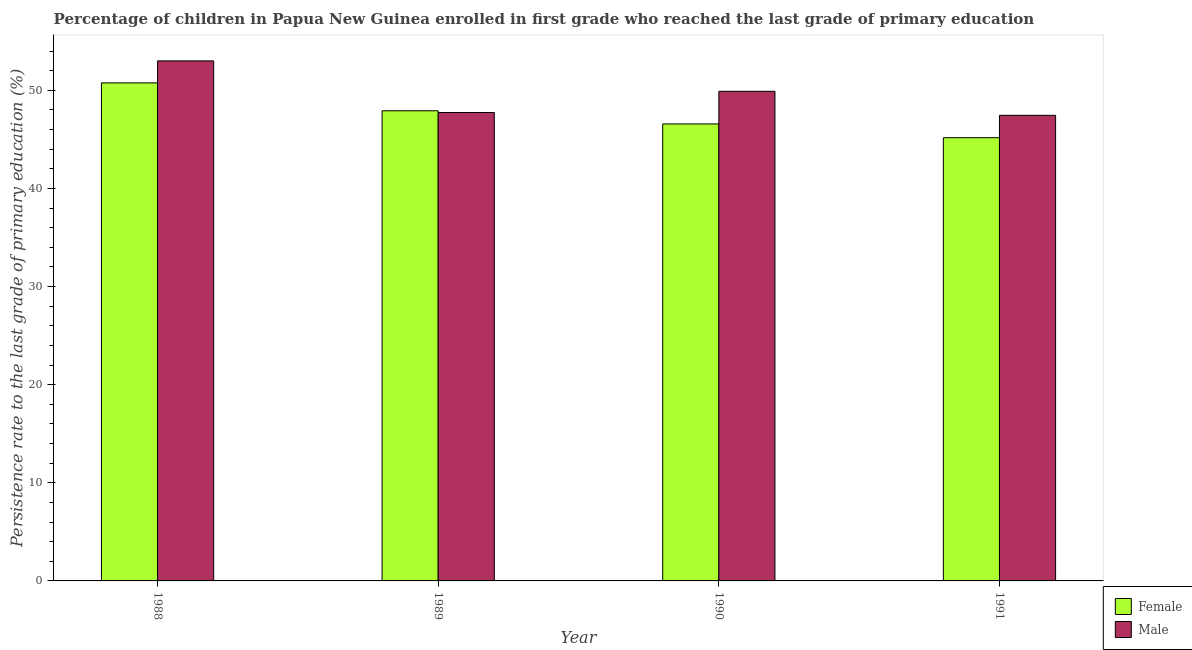How many different coloured bars are there?
Keep it short and to the point. 2. How many groups of bars are there?
Ensure brevity in your answer.  4. Are the number of bars per tick equal to the number of legend labels?
Provide a succinct answer. Yes. How many bars are there on the 3rd tick from the right?
Give a very brief answer. 2. What is the label of the 2nd group of bars from the left?
Provide a succinct answer. 1989. What is the persistence rate of female students in 1990?
Your answer should be very brief. 46.58. Across all years, what is the maximum persistence rate of male students?
Provide a succinct answer. 53.01. Across all years, what is the minimum persistence rate of female students?
Your answer should be compact. 45.18. In which year was the persistence rate of male students maximum?
Your response must be concise. 1988. What is the total persistence rate of male students in the graph?
Keep it short and to the point. 198.11. What is the difference between the persistence rate of female students in 1988 and that in 1991?
Your response must be concise. 5.58. What is the difference between the persistence rate of male students in 1988 and the persistence rate of female students in 1989?
Offer a terse response. 5.26. What is the average persistence rate of male students per year?
Your answer should be very brief. 49.53. In how many years, is the persistence rate of female students greater than 44 %?
Offer a very short reply. 4. What is the ratio of the persistence rate of female students in 1989 to that in 1990?
Provide a succinct answer. 1.03. What is the difference between the highest and the second highest persistence rate of male students?
Provide a succinct answer. 3.1. What is the difference between the highest and the lowest persistence rate of female students?
Your response must be concise. 5.58. In how many years, is the persistence rate of male students greater than the average persistence rate of male students taken over all years?
Provide a short and direct response. 2. What does the 1st bar from the right in 1988 represents?
Your answer should be very brief. Male. What is the difference between two consecutive major ticks on the Y-axis?
Your response must be concise. 10. Are the values on the major ticks of Y-axis written in scientific E-notation?
Provide a short and direct response. No. Does the graph contain any zero values?
Your response must be concise. No. Where does the legend appear in the graph?
Provide a short and direct response. Bottom right. How many legend labels are there?
Offer a terse response. 2. How are the legend labels stacked?
Offer a terse response. Vertical. What is the title of the graph?
Make the answer very short. Percentage of children in Papua New Guinea enrolled in first grade who reached the last grade of primary education. What is the label or title of the X-axis?
Your answer should be very brief. Year. What is the label or title of the Y-axis?
Make the answer very short. Persistence rate to the last grade of primary education (%). What is the Persistence rate to the last grade of primary education (%) of Female in 1988?
Provide a short and direct response. 50.76. What is the Persistence rate to the last grade of primary education (%) of Male in 1988?
Offer a very short reply. 53.01. What is the Persistence rate to the last grade of primary education (%) in Female in 1989?
Make the answer very short. 47.92. What is the Persistence rate to the last grade of primary education (%) of Male in 1989?
Ensure brevity in your answer.  47.74. What is the Persistence rate to the last grade of primary education (%) in Female in 1990?
Provide a succinct answer. 46.58. What is the Persistence rate to the last grade of primary education (%) in Male in 1990?
Give a very brief answer. 49.9. What is the Persistence rate to the last grade of primary education (%) in Female in 1991?
Your answer should be compact. 45.18. What is the Persistence rate to the last grade of primary education (%) in Male in 1991?
Your answer should be compact. 47.46. Across all years, what is the maximum Persistence rate to the last grade of primary education (%) in Female?
Give a very brief answer. 50.76. Across all years, what is the maximum Persistence rate to the last grade of primary education (%) in Male?
Offer a terse response. 53.01. Across all years, what is the minimum Persistence rate to the last grade of primary education (%) of Female?
Your answer should be compact. 45.18. Across all years, what is the minimum Persistence rate to the last grade of primary education (%) in Male?
Your answer should be compact. 47.46. What is the total Persistence rate to the last grade of primary education (%) in Female in the graph?
Offer a very short reply. 190.43. What is the total Persistence rate to the last grade of primary education (%) in Male in the graph?
Your answer should be compact. 198.11. What is the difference between the Persistence rate to the last grade of primary education (%) in Female in 1988 and that in 1989?
Offer a very short reply. 2.84. What is the difference between the Persistence rate to the last grade of primary education (%) in Male in 1988 and that in 1989?
Make the answer very short. 5.26. What is the difference between the Persistence rate to the last grade of primary education (%) in Female in 1988 and that in 1990?
Provide a short and direct response. 4.18. What is the difference between the Persistence rate to the last grade of primary education (%) of Male in 1988 and that in 1990?
Make the answer very short. 3.1. What is the difference between the Persistence rate to the last grade of primary education (%) of Female in 1988 and that in 1991?
Offer a terse response. 5.58. What is the difference between the Persistence rate to the last grade of primary education (%) in Male in 1988 and that in 1991?
Make the answer very short. 5.55. What is the difference between the Persistence rate to the last grade of primary education (%) of Female in 1989 and that in 1990?
Keep it short and to the point. 1.34. What is the difference between the Persistence rate to the last grade of primary education (%) of Male in 1989 and that in 1990?
Provide a short and direct response. -2.16. What is the difference between the Persistence rate to the last grade of primary education (%) in Female in 1989 and that in 1991?
Keep it short and to the point. 2.74. What is the difference between the Persistence rate to the last grade of primary education (%) of Male in 1989 and that in 1991?
Make the answer very short. 0.29. What is the difference between the Persistence rate to the last grade of primary education (%) of Female in 1990 and that in 1991?
Keep it short and to the point. 1.4. What is the difference between the Persistence rate to the last grade of primary education (%) in Male in 1990 and that in 1991?
Your answer should be compact. 2.45. What is the difference between the Persistence rate to the last grade of primary education (%) in Female in 1988 and the Persistence rate to the last grade of primary education (%) in Male in 1989?
Provide a succinct answer. 3.02. What is the difference between the Persistence rate to the last grade of primary education (%) of Female in 1988 and the Persistence rate to the last grade of primary education (%) of Male in 1990?
Give a very brief answer. 0.86. What is the difference between the Persistence rate to the last grade of primary education (%) in Female in 1988 and the Persistence rate to the last grade of primary education (%) in Male in 1991?
Keep it short and to the point. 3.3. What is the difference between the Persistence rate to the last grade of primary education (%) in Female in 1989 and the Persistence rate to the last grade of primary education (%) in Male in 1990?
Provide a succinct answer. -1.99. What is the difference between the Persistence rate to the last grade of primary education (%) of Female in 1989 and the Persistence rate to the last grade of primary education (%) of Male in 1991?
Offer a very short reply. 0.46. What is the difference between the Persistence rate to the last grade of primary education (%) of Female in 1990 and the Persistence rate to the last grade of primary education (%) of Male in 1991?
Keep it short and to the point. -0.88. What is the average Persistence rate to the last grade of primary education (%) of Female per year?
Offer a terse response. 47.61. What is the average Persistence rate to the last grade of primary education (%) of Male per year?
Your response must be concise. 49.53. In the year 1988, what is the difference between the Persistence rate to the last grade of primary education (%) of Female and Persistence rate to the last grade of primary education (%) of Male?
Provide a succinct answer. -2.25. In the year 1989, what is the difference between the Persistence rate to the last grade of primary education (%) in Female and Persistence rate to the last grade of primary education (%) in Male?
Give a very brief answer. 0.18. In the year 1990, what is the difference between the Persistence rate to the last grade of primary education (%) of Female and Persistence rate to the last grade of primary education (%) of Male?
Keep it short and to the point. -3.33. In the year 1991, what is the difference between the Persistence rate to the last grade of primary education (%) of Female and Persistence rate to the last grade of primary education (%) of Male?
Your response must be concise. -2.28. What is the ratio of the Persistence rate to the last grade of primary education (%) of Female in 1988 to that in 1989?
Offer a very short reply. 1.06. What is the ratio of the Persistence rate to the last grade of primary education (%) in Male in 1988 to that in 1989?
Keep it short and to the point. 1.11. What is the ratio of the Persistence rate to the last grade of primary education (%) in Female in 1988 to that in 1990?
Keep it short and to the point. 1.09. What is the ratio of the Persistence rate to the last grade of primary education (%) in Male in 1988 to that in 1990?
Give a very brief answer. 1.06. What is the ratio of the Persistence rate to the last grade of primary education (%) of Female in 1988 to that in 1991?
Give a very brief answer. 1.12. What is the ratio of the Persistence rate to the last grade of primary education (%) of Male in 1988 to that in 1991?
Your answer should be very brief. 1.12. What is the ratio of the Persistence rate to the last grade of primary education (%) of Female in 1989 to that in 1990?
Provide a short and direct response. 1.03. What is the ratio of the Persistence rate to the last grade of primary education (%) of Male in 1989 to that in 1990?
Provide a short and direct response. 0.96. What is the ratio of the Persistence rate to the last grade of primary education (%) of Female in 1989 to that in 1991?
Keep it short and to the point. 1.06. What is the ratio of the Persistence rate to the last grade of primary education (%) of Female in 1990 to that in 1991?
Keep it short and to the point. 1.03. What is the ratio of the Persistence rate to the last grade of primary education (%) in Male in 1990 to that in 1991?
Ensure brevity in your answer.  1.05. What is the difference between the highest and the second highest Persistence rate to the last grade of primary education (%) of Female?
Your answer should be compact. 2.84. What is the difference between the highest and the second highest Persistence rate to the last grade of primary education (%) of Male?
Your response must be concise. 3.1. What is the difference between the highest and the lowest Persistence rate to the last grade of primary education (%) in Female?
Your answer should be compact. 5.58. What is the difference between the highest and the lowest Persistence rate to the last grade of primary education (%) of Male?
Your answer should be very brief. 5.55. 